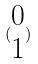<formula> <loc_0><loc_0><loc_500><loc_500>( \begin{matrix} 0 \\ 1 \end{matrix} )</formula> 